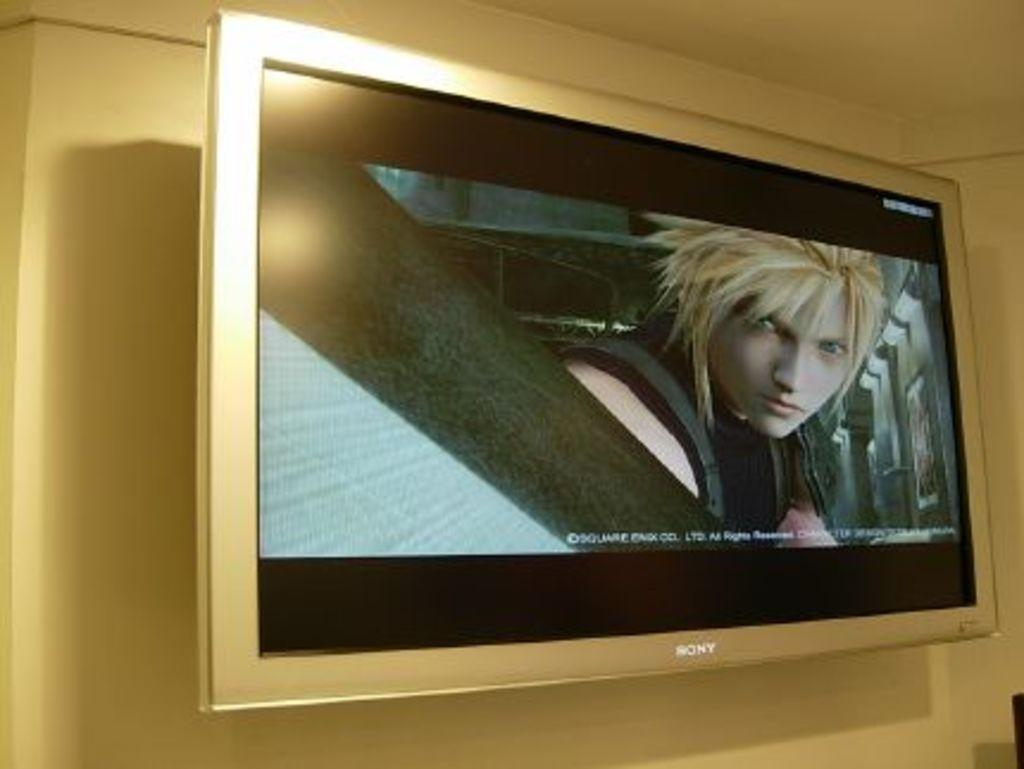What brand of television is visible in the image? There is a Sony television in the image. How is the television positioned in the image? The television is attached to the wall. What is the television displaying in the image? The television is displaying a picture. How many pigs are visible on the screen of the television in the image? There are no pigs visible on the screen of the television in the image. 